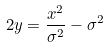<formula> <loc_0><loc_0><loc_500><loc_500>2 y = \frac { x ^ { 2 } } { \sigma ^ { 2 } } - \sigma ^ { 2 }</formula> 